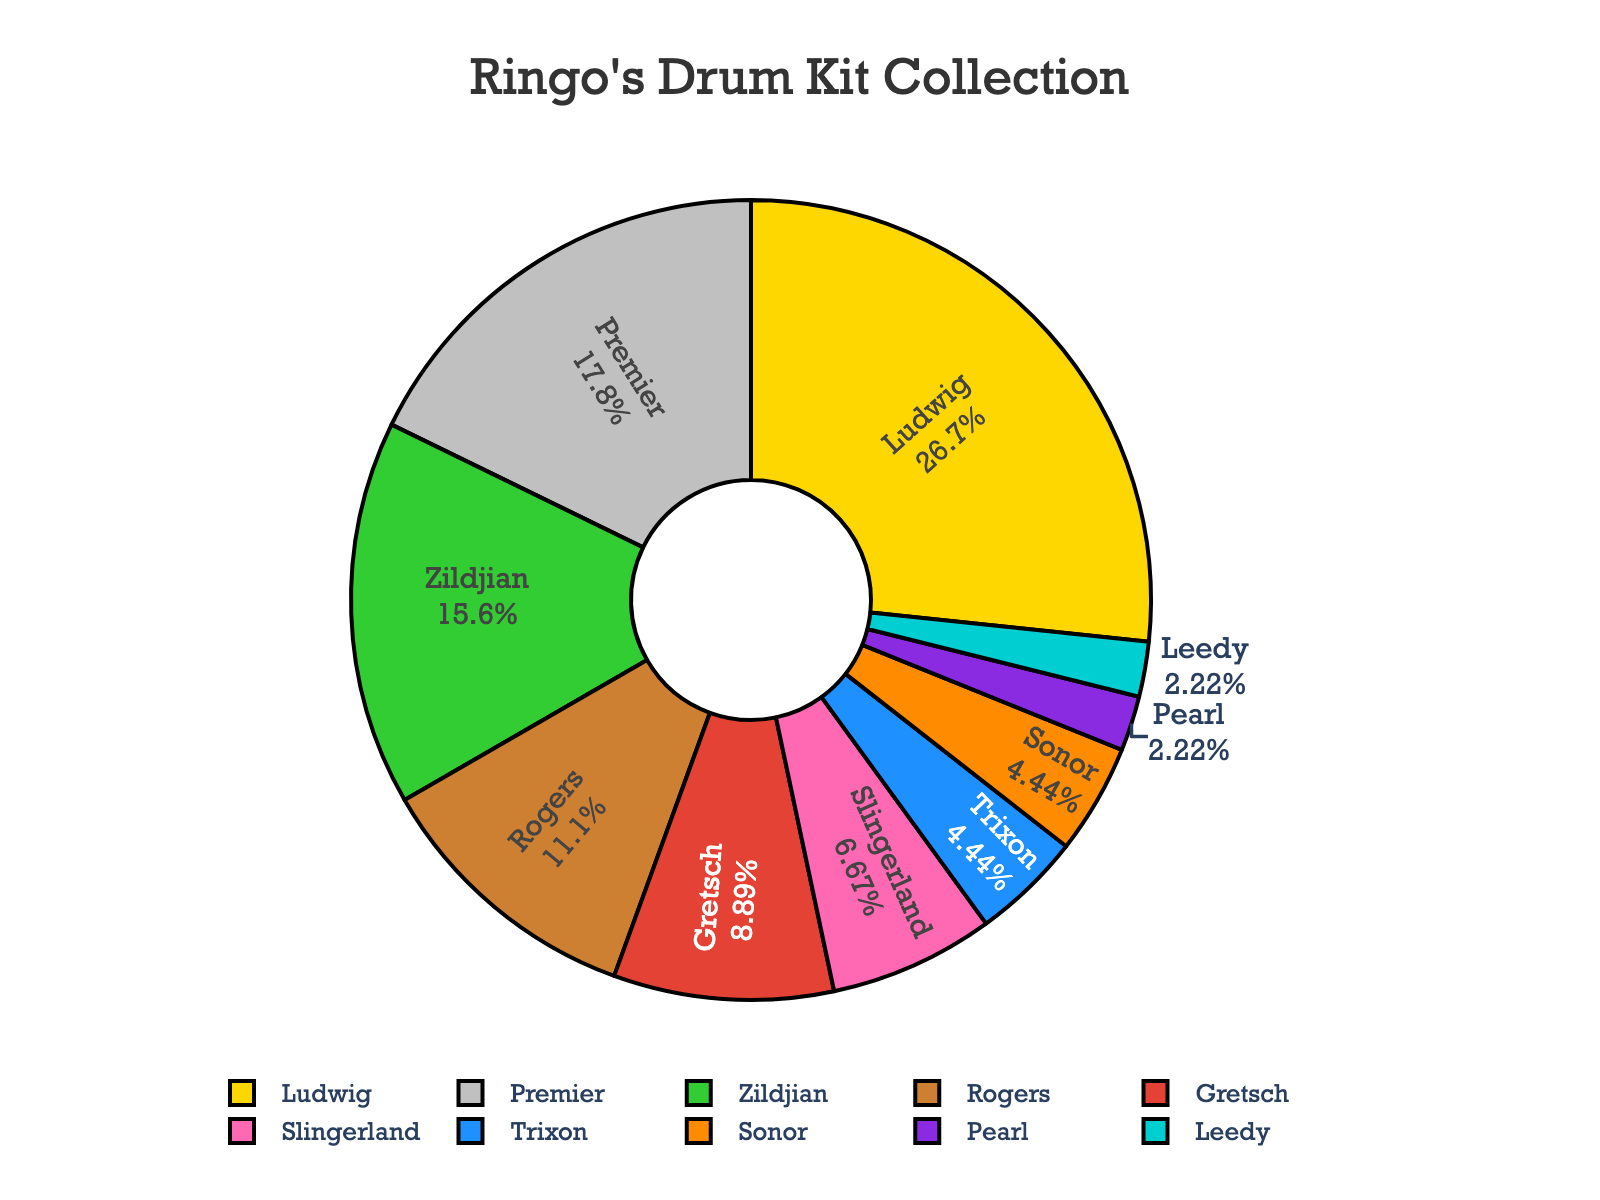Which manufacturer has the highest quantity of drum kits in Ringo's collection? To find the manufacturer with the highest quantity, we look at the section of the pie chart with the largest size. This is labeled "Ludwig" in the chart.
Answer: Ludwig What percentage of the total does Premier contribute to Ringo's collection? The pie chart shows the percentage contributions of each manufacturer next to their names. Premier’s section is labeled with its percentage.
Answer: 21% Which two manufacturers have the same number of drum kits in Ringo's collection? By examining the labels, two manufacturers are shown to have the same quantity: Trixon and Sonor both have 2 drum kits.
Answer: Trixon and Sonor How many more drum kits does Ludwig have compared to Rogers? Ludwig has 12 drum kits and Rogers has 5. The difference is calculated as 12 - 5 = 7.
Answer: 7 What is the total number of drum kits from Gretsch and Slingerland combined? Gretsch has 4 drum kits and Slingerland has 3. The total is computed as 4 + 3 = 7.
Answer: 7 Which manufacturer contributes the smallest proportion to Ringo's collection? The smallest section of the pie chart represents Pearl and Leedy, both having the smallest number of drum kits, which is 1 each.
Answer: Pearl and Leedy Compare the total quantity of Zildjian drum kits to the combined total of Sonor and Leedy. Which is more? Zildjian has 7, Sonor has 2, and Leedy has 1. Combined, Sonor and Leedy have 2 + 1 = 3. Zildjian's 7 is more than the combined total of Sonor and Leedy.
Answer: Zildjian What's the average number of drum kits across all manufacturers? First, sum the quantities: 12 (Ludwig) + 8 (Premier) + 5 (Rogers) + 4 (Gretsch) + 2 (Trixon) + 7 (Zildjian) + 3 (Slingerland) + 1 (Pearl) + 2 (Sonor) + 1 (Leedy) = 45. There are 10 manufacturers, so the average is 45 / 10 = 4.5.
Answer: 4.5 If Ringo decides to add 2 more kits from Gretsch, what percentage of his collection will now be from Gretsch? Initially, Gretsch has 4 kits. Adding 2 more makes it 6. The new total number of kits is 45 + 2 = 47. The percentage is (6 / 47) * 100 ≈ 12.77%.
Answer: 12.77% Which drum kit manufacturer is associated with the color blue in the pie chart? By inspecting the color coding of the pie chart, it shows that Rogers is associated with the color blue.
Answer: Rogers 